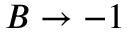Convert formula to latex. <formula><loc_0><loc_0><loc_500><loc_500>B \rightarrow - 1</formula> 